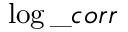<formula> <loc_0><loc_0><loc_500><loc_500>\log \_ c o r r</formula> 